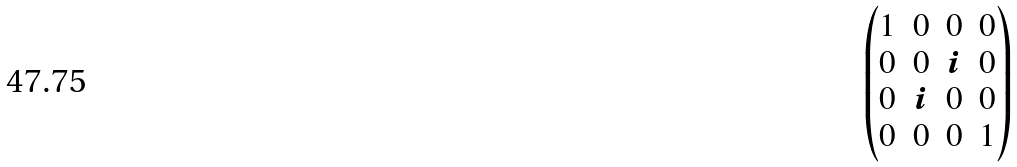<formula> <loc_0><loc_0><loc_500><loc_500>\begin{pmatrix} 1 & 0 & 0 & 0 \\ 0 & 0 & i & 0 \\ 0 & i & 0 & 0 \\ 0 & 0 & 0 & 1 \end{pmatrix}</formula> 